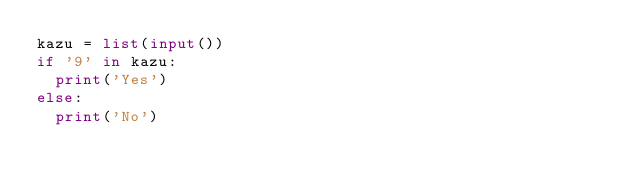<code> <loc_0><loc_0><loc_500><loc_500><_Python_>kazu = list(input())
if '9' in kazu:
  print('Yes')
else:
  print('No')</code> 